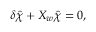<formula> <loc_0><loc_0><loc_500><loc_500>\delta \hat { \chi } + X _ { w } \hat { \chi } = 0 ,</formula> 